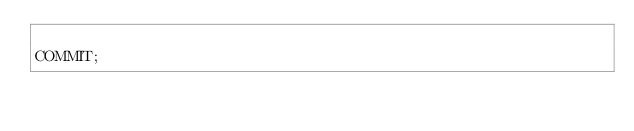Convert code to text. <code><loc_0><loc_0><loc_500><loc_500><_SQL_>
COMMIT;
</code> 